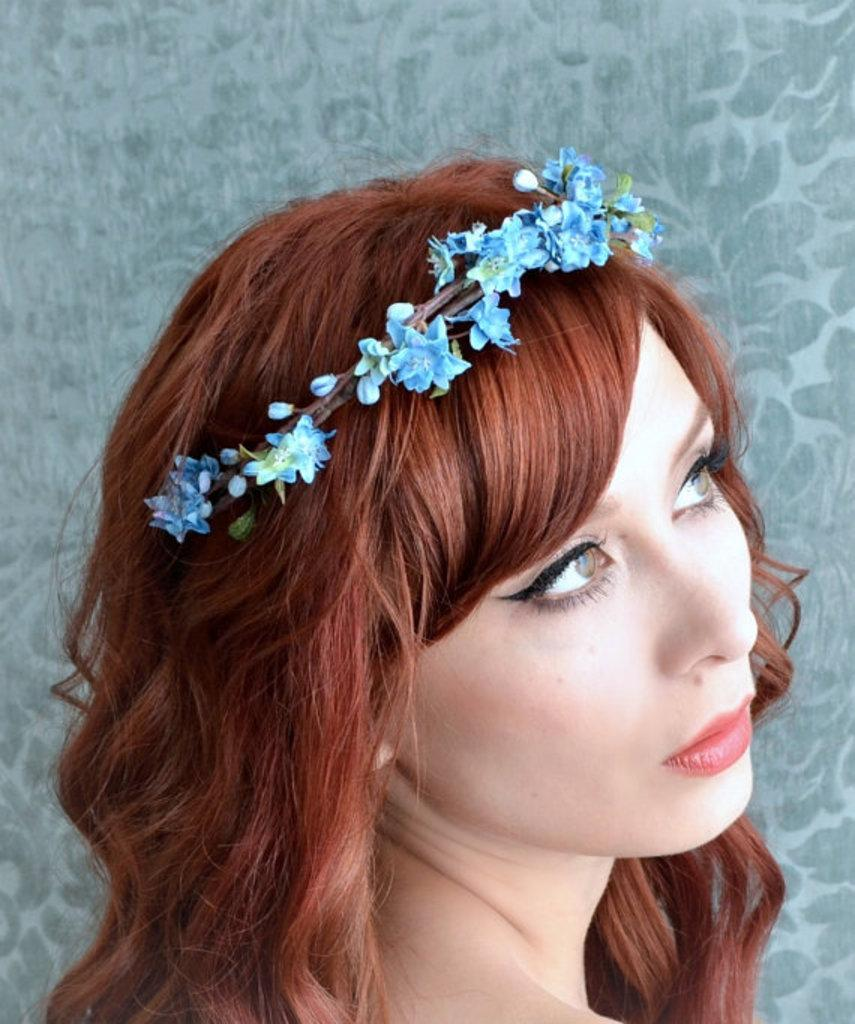Who is present in the image? There is a woman in the image. What is a notable feature of the woman's appearance? The woman has blonde hair. What is the woman wearing on her head? The woman is wearing a floral headgear. Who or what is the woman looking at? The woman is looking at someone. What type of blood is visible on the woman's floral headgear? There is no blood visible on the woman's floral headgear in the image. How many goldfish are swimming in the woman's hair? There are no goldfish present in the image. 